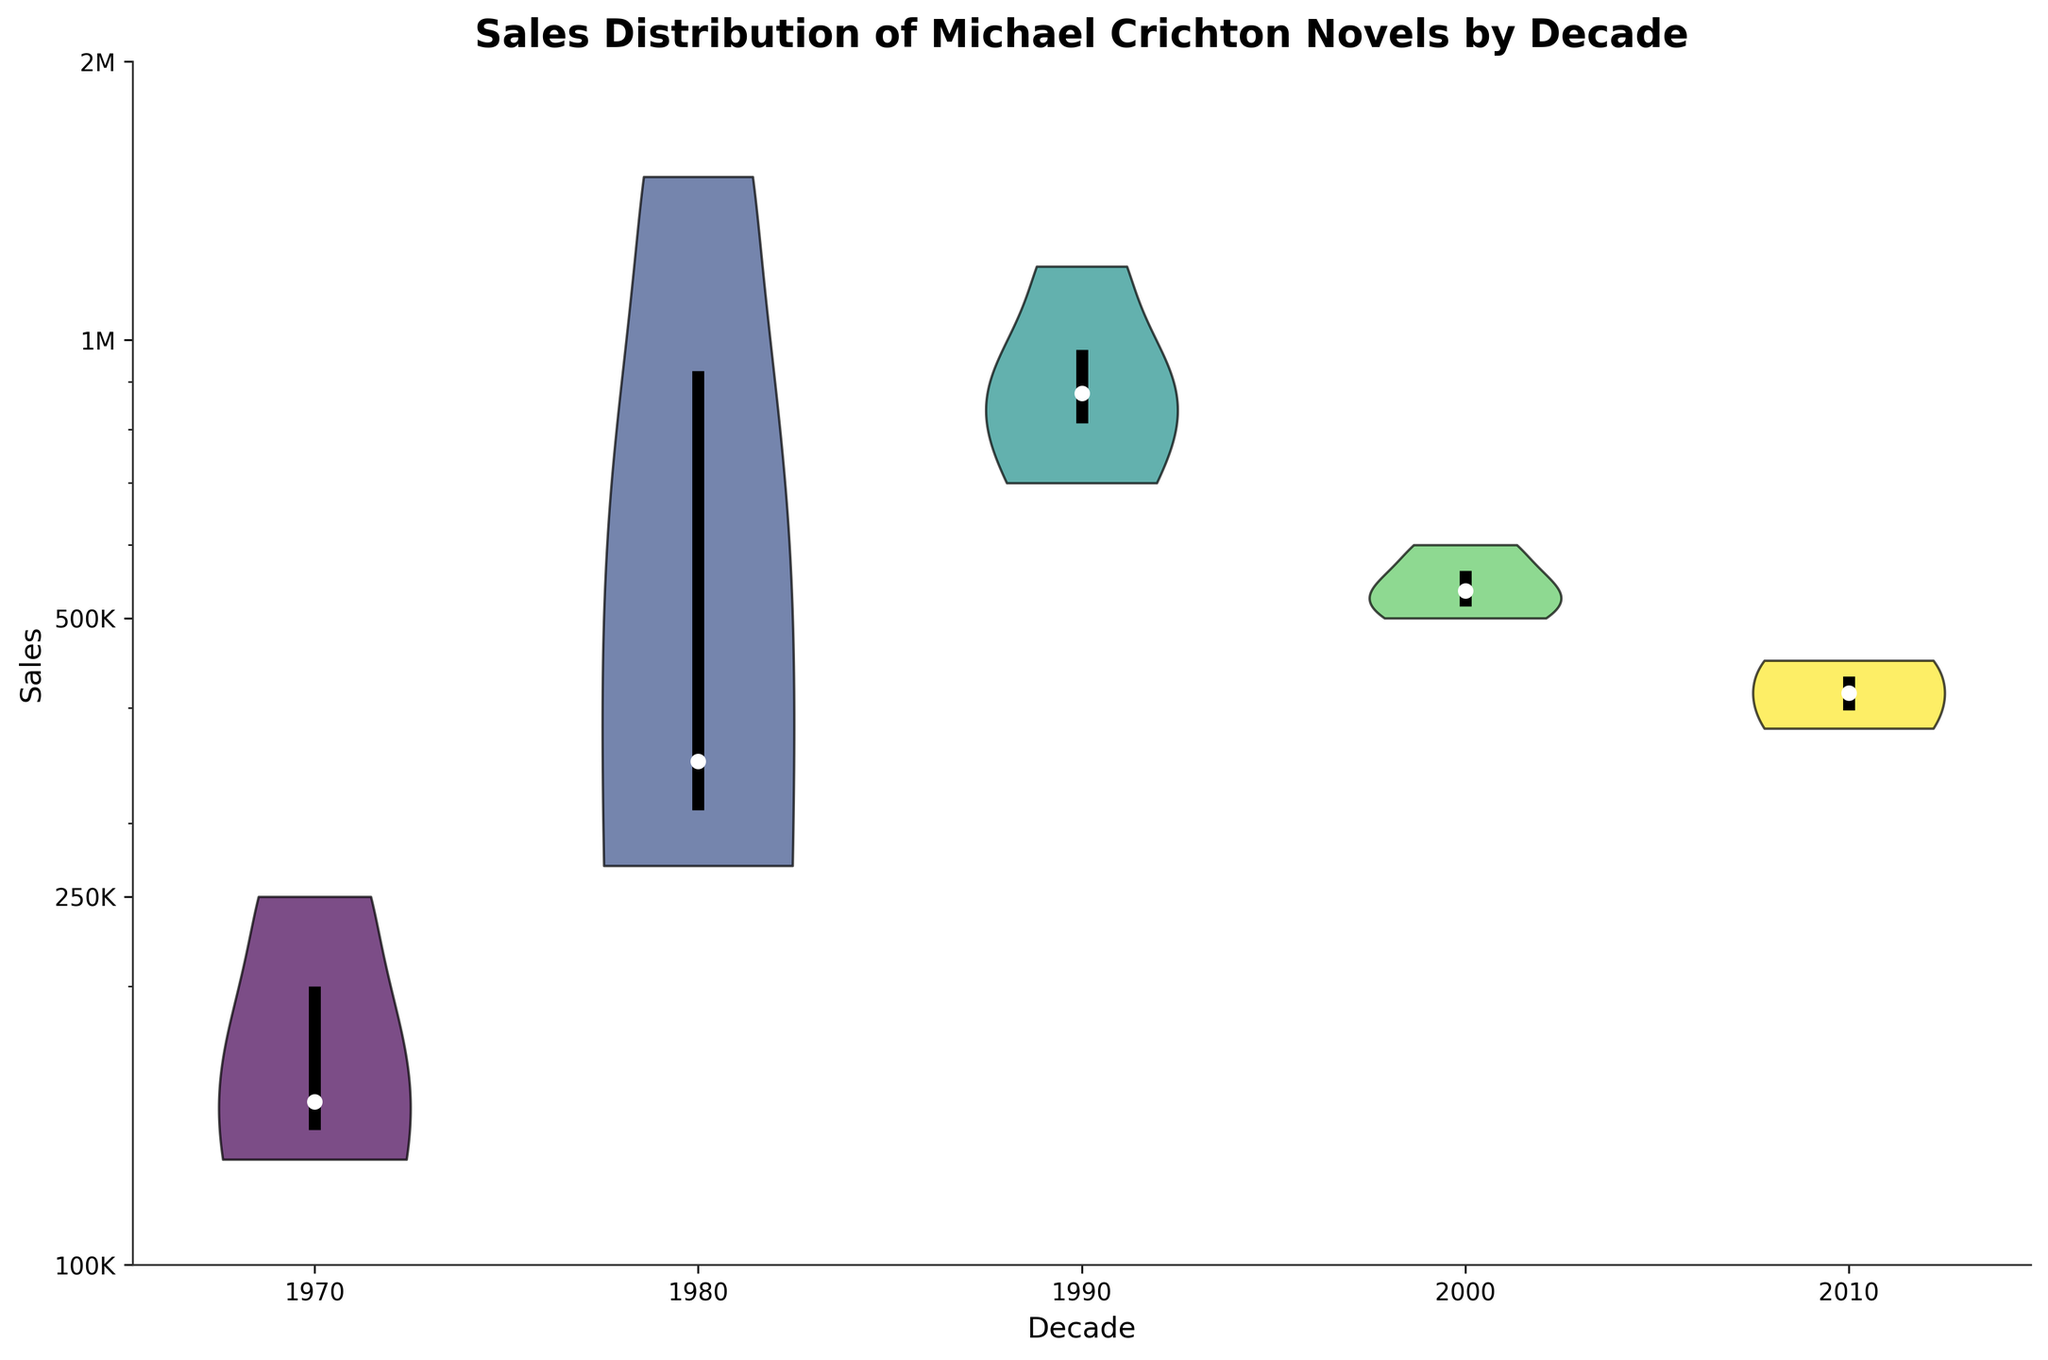How many decades are represented in the chart? The chart has different violin plots for each decade, and the x-axis shows the decade labels. Counting the distinct labels can determine the number of decades.
Answer: 5 Which decade has the highest median sales value? Look for the decade where the white dot, representing the median of the violin plot, is the highest on the y-axis.
Answer: 1990 What's the range of sales in the 1980s? Identify the top and bottom edges of the 1980s violin plot. Then check the y-axis values these points correspond to.
Answer: 130,000 to 1,500,000 How does the spread of sales in the 2010s compare to the 2000s? Compare the width of the violin plots for the 2010s and 2000s. The wider the plot, the more spread out the sales distribution.
Answer: 2010s has a narrower spread What's the most common value for sales in the 1990s? The most common value is where the violin plot bulges the most. For the 1990s, look at its widest point.
Answer: Around 850,000 to 1,200,000 Which decade has the most outliers in sales? Look for the decade where the points extend furthest from the main body of the violin plot. Outliers typically appear as points far away from the violin's bulk.
Answer: 1980 How does the third quartile of sales in the 1970s compare to the medians in the 2000s and 2010s? Find the third quartile (upper edge of the interquartile range line) on the 1970s plot, then compare it to the medians (white dots) of the 2000s and 2010s plots.
Answer: Higher than 2000s and comparable to 2010s What is the overall trend in sales across the decades? Observe the general shape of the violin plots and the position of the medians across decades. Determine whether there's an increase, decrease, or no trend.
Answer: Increase in the 1980s and 1990s, then a decrease 